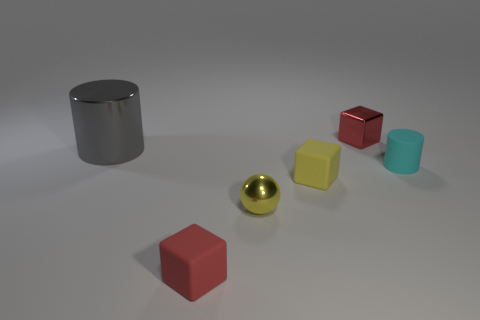Add 2 tiny red metal cubes. How many objects exist? 8 Subtract all cylinders. How many objects are left? 4 Add 4 large gray cylinders. How many large gray cylinders are left? 5 Add 3 gray matte cylinders. How many gray matte cylinders exist? 3 Subtract 1 yellow spheres. How many objects are left? 5 Subtract all small red metallic objects. Subtract all tiny cyan rubber cylinders. How many objects are left? 4 